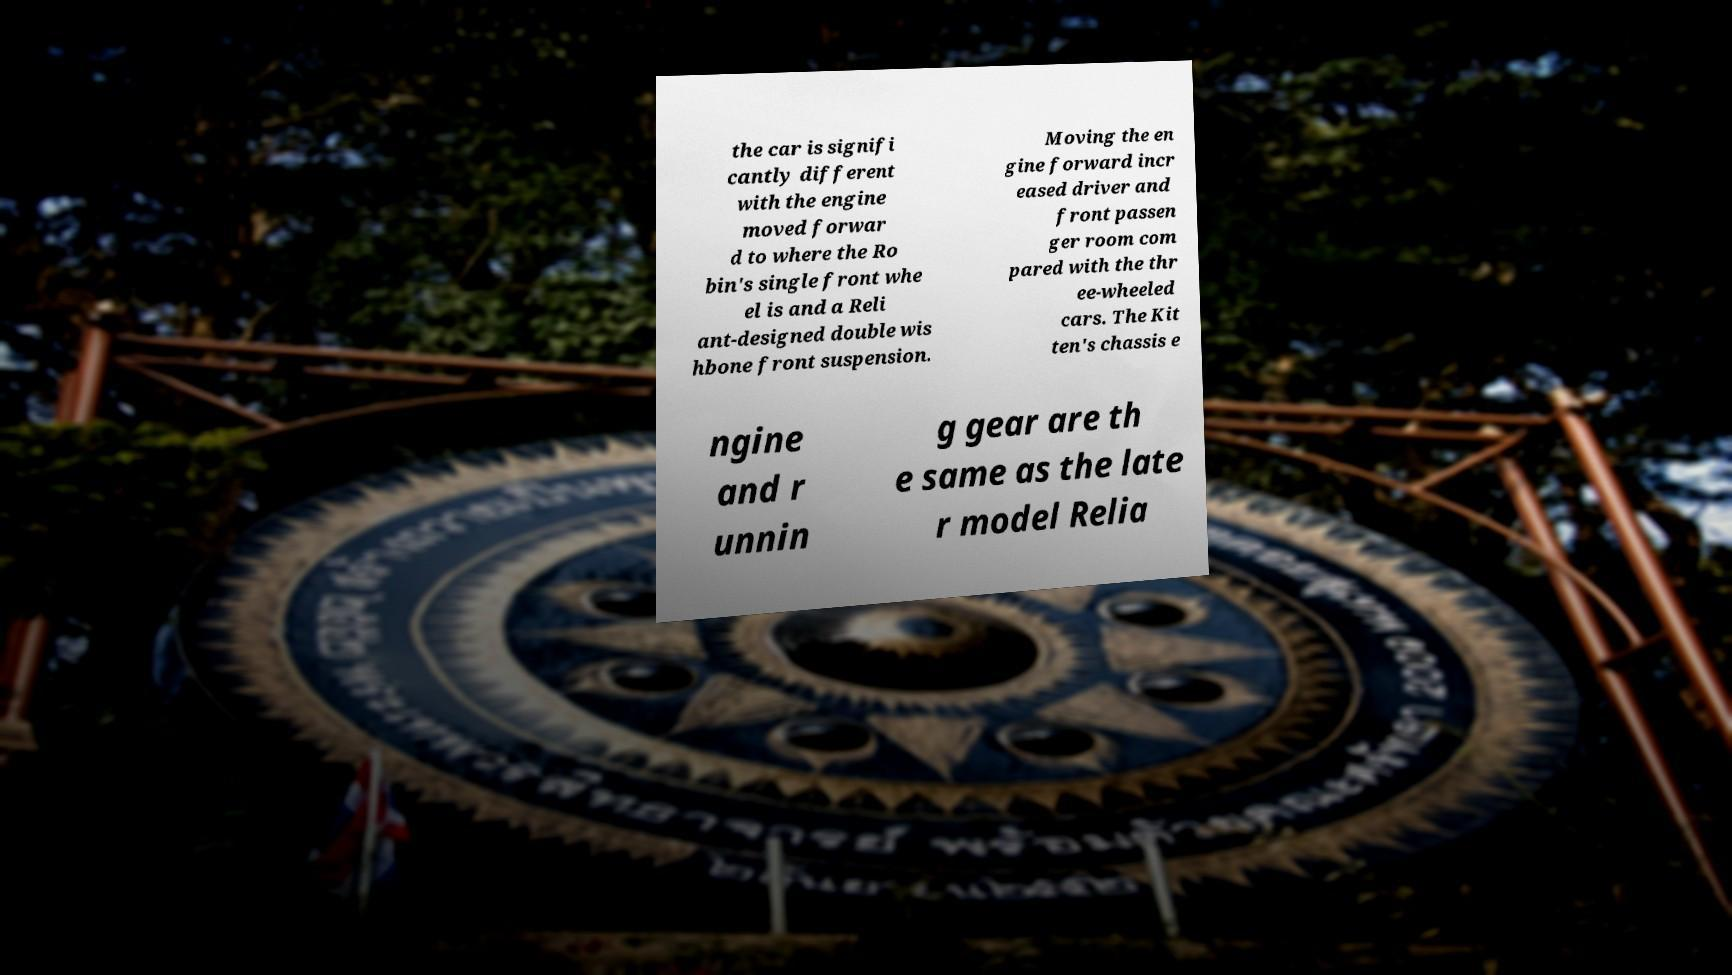I need the written content from this picture converted into text. Can you do that? the car is signifi cantly different with the engine moved forwar d to where the Ro bin's single front whe el is and a Reli ant-designed double wis hbone front suspension. Moving the en gine forward incr eased driver and front passen ger room com pared with the thr ee-wheeled cars. The Kit ten's chassis e ngine and r unnin g gear are th e same as the late r model Relia 